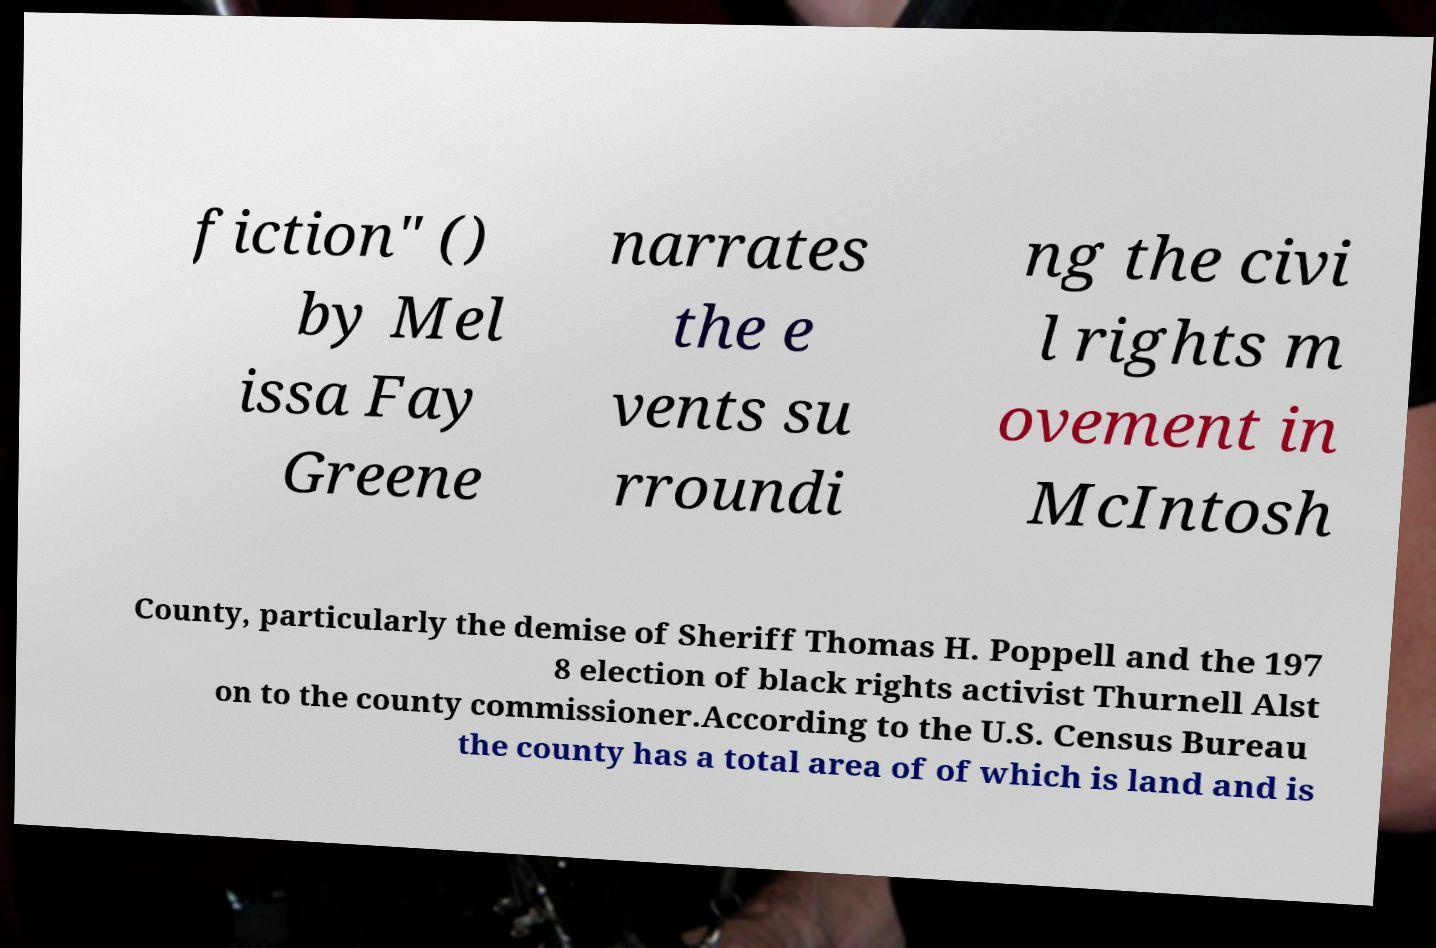There's text embedded in this image that I need extracted. Can you transcribe it verbatim? fiction" () by Mel issa Fay Greene narrates the e vents su rroundi ng the civi l rights m ovement in McIntosh County, particularly the demise of Sheriff Thomas H. Poppell and the 197 8 election of black rights activist Thurnell Alst on to the county commissioner.According to the U.S. Census Bureau the county has a total area of of which is land and is 